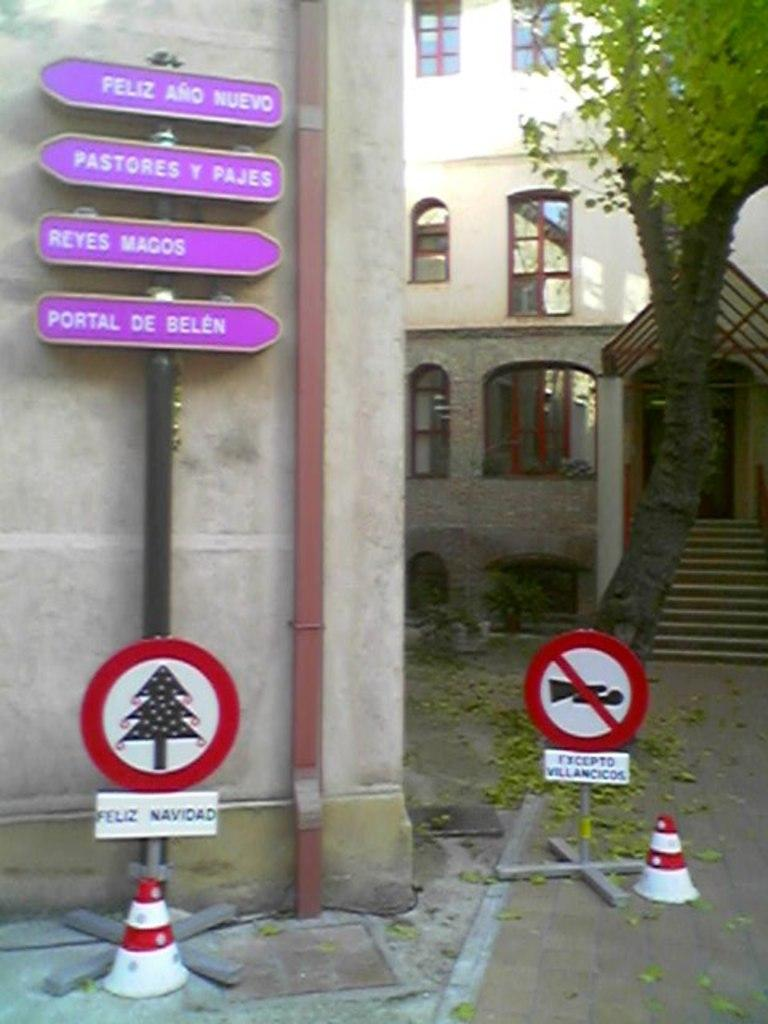Provide a one-sentence caption for the provided image. A little sign with a Christmas tree on it says "Feliz Navidad.". 